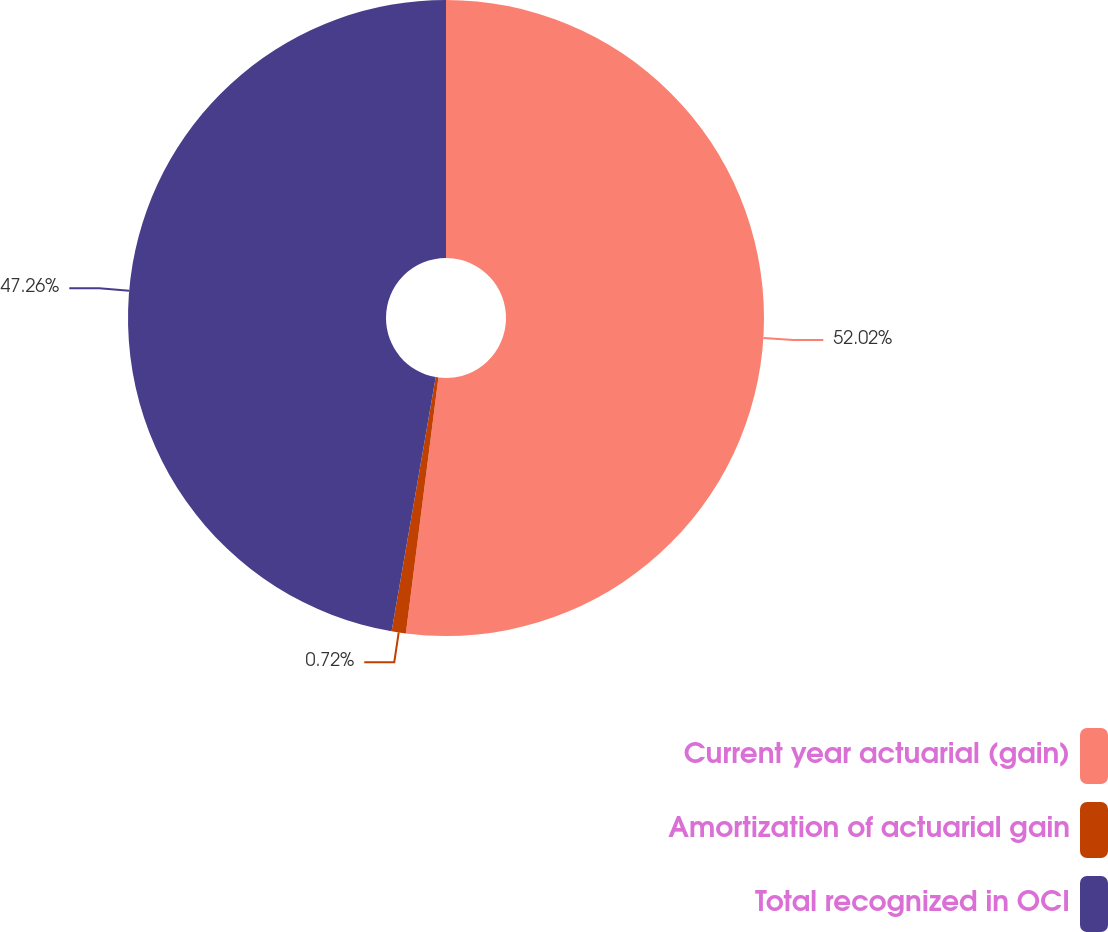Convert chart. <chart><loc_0><loc_0><loc_500><loc_500><pie_chart><fcel>Current year actuarial (gain)<fcel>Amortization of actuarial gain<fcel>Total recognized in OCI<nl><fcel>52.01%<fcel>0.72%<fcel>47.26%<nl></chart> 